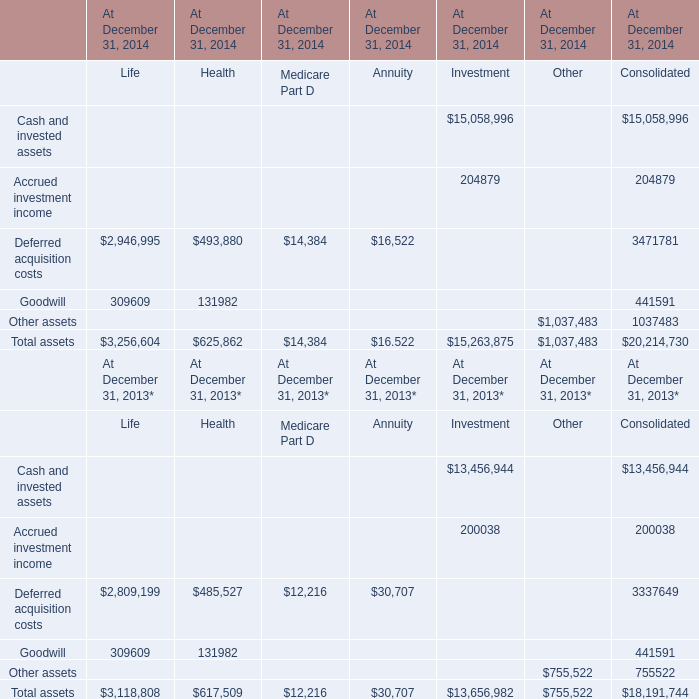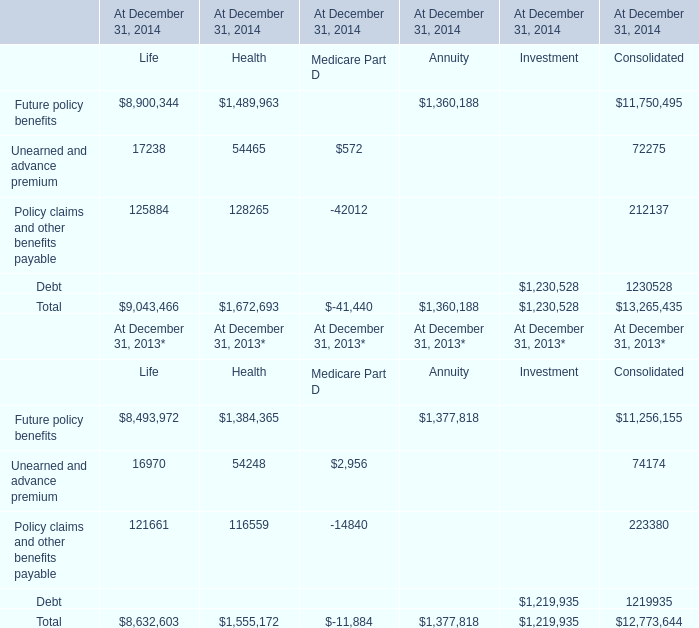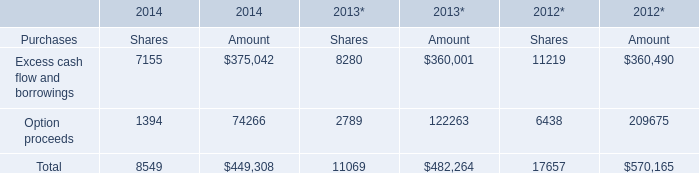What is the total amount of Cash and invested assets of At December 31, 2014 Consolidated, and Option proceeds of 2013* Amount ? 
Computations: (13456944.0 + 122263.0)
Answer: 13579207.0. 